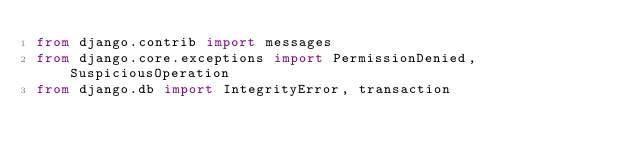Convert code to text. <code><loc_0><loc_0><loc_500><loc_500><_Python_>from django.contrib import messages
from django.core.exceptions import PermissionDenied, SuspiciousOperation
from django.db import IntegrityError, transaction</code> 